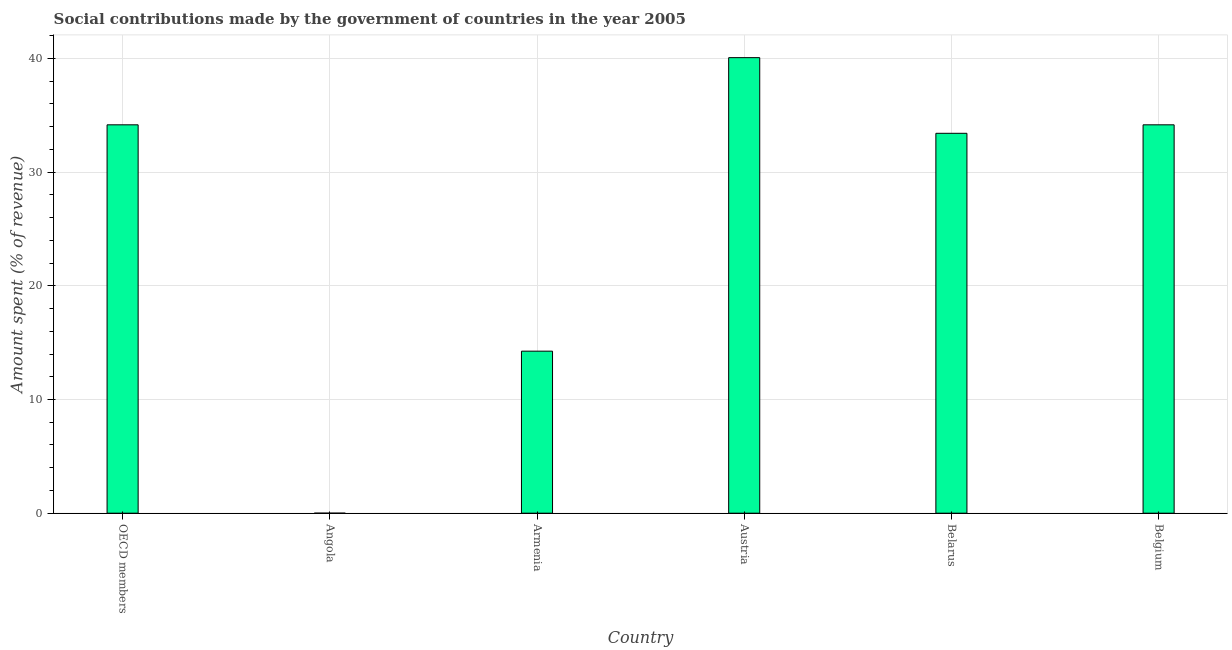Does the graph contain any zero values?
Provide a short and direct response. No. Does the graph contain grids?
Ensure brevity in your answer.  Yes. What is the title of the graph?
Offer a very short reply. Social contributions made by the government of countries in the year 2005. What is the label or title of the Y-axis?
Ensure brevity in your answer.  Amount spent (% of revenue). What is the amount spent in making social contributions in Armenia?
Offer a very short reply. 14.25. Across all countries, what is the maximum amount spent in making social contributions?
Offer a very short reply. 40.08. Across all countries, what is the minimum amount spent in making social contributions?
Make the answer very short. 0. In which country was the amount spent in making social contributions minimum?
Ensure brevity in your answer.  Angola. What is the sum of the amount spent in making social contributions?
Ensure brevity in your answer.  156.09. What is the difference between the amount spent in making social contributions in Angola and OECD members?
Your answer should be compact. -34.16. What is the average amount spent in making social contributions per country?
Give a very brief answer. 26.02. What is the median amount spent in making social contributions?
Give a very brief answer. 33.79. In how many countries, is the amount spent in making social contributions greater than 18 %?
Keep it short and to the point. 4. What is the ratio of the amount spent in making social contributions in Armenia to that in Belgium?
Offer a terse response. 0.42. Is the amount spent in making social contributions in Armenia less than that in Austria?
Ensure brevity in your answer.  Yes. Is the difference between the amount spent in making social contributions in Belarus and Belgium greater than the difference between any two countries?
Ensure brevity in your answer.  No. What is the difference between the highest and the second highest amount spent in making social contributions?
Provide a short and direct response. 5.91. Is the sum of the amount spent in making social contributions in Angola and Belgium greater than the maximum amount spent in making social contributions across all countries?
Make the answer very short. No. What is the difference between the highest and the lowest amount spent in making social contributions?
Keep it short and to the point. 40.07. In how many countries, is the amount spent in making social contributions greater than the average amount spent in making social contributions taken over all countries?
Offer a very short reply. 4. How many bars are there?
Offer a terse response. 6. What is the difference between two consecutive major ticks on the Y-axis?
Ensure brevity in your answer.  10. Are the values on the major ticks of Y-axis written in scientific E-notation?
Your response must be concise. No. What is the Amount spent (% of revenue) in OECD members?
Keep it short and to the point. 34.17. What is the Amount spent (% of revenue) of Angola?
Your answer should be very brief. 0. What is the Amount spent (% of revenue) of Armenia?
Your response must be concise. 14.25. What is the Amount spent (% of revenue) of Austria?
Offer a terse response. 40.08. What is the Amount spent (% of revenue) in Belarus?
Ensure brevity in your answer.  33.42. What is the Amount spent (% of revenue) of Belgium?
Provide a short and direct response. 34.17. What is the difference between the Amount spent (% of revenue) in OECD members and Angola?
Give a very brief answer. 34.16. What is the difference between the Amount spent (% of revenue) in OECD members and Armenia?
Your answer should be very brief. 19.91. What is the difference between the Amount spent (% of revenue) in OECD members and Austria?
Your answer should be very brief. -5.91. What is the difference between the Amount spent (% of revenue) in OECD members and Belarus?
Your answer should be very brief. 0.75. What is the difference between the Amount spent (% of revenue) in OECD members and Belgium?
Keep it short and to the point. 0. What is the difference between the Amount spent (% of revenue) in Angola and Armenia?
Your response must be concise. -14.25. What is the difference between the Amount spent (% of revenue) in Angola and Austria?
Offer a very short reply. -40.07. What is the difference between the Amount spent (% of revenue) in Angola and Belarus?
Make the answer very short. -33.42. What is the difference between the Amount spent (% of revenue) in Angola and Belgium?
Offer a very short reply. -34.16. What is the difference between the Amount spent (% of revenue) in Armenia and Austria?
Make the answer very short. -25.82. What is the difference between the Amount spent (% of revenue) in Armenia and Belarus?
Your answer should be very brief. -19.17. What is the difference between the Amount spent (% of revenue) in Armenia and Belgium?
Offer a very short reply. -19.91. What is the difference between the Amount spent (% of revenue) in Austria and Belarus?
Provide a short and direct response. 6.65. What is the difference between the Amount spent (% of revenue) in Austria and Belgium?
Your response must be concise. 5.91. What is the difference between the Amount spent (% of revenue) in Belarus and Belgium?
Offer a terse response. -0.75. What is the ratio of the Amount spent (% of revenue) in OECD members to that in Angola?
Your response must be concise. 1.10e+04. What is the ratio of the Amount spent (% of revenue) in OECD members to that in Armenia?
Provide a short and direct response. 2.4. What is the ratio of the Amount spent (% of revenue) in OECD members to that in Austria?
Your answer should be compact. 0.85. What is the ratio of the Amount spent (% of revenue) in OECD members to that in Belarus?
Keep it short and to the point. 1.02. What is the ratio of the Amount spent (% of revenue) in OECD members to that in Belgium?
Ensure brevity in your answer.  1. What is the ratio of the Amount spent (% of revenue) in Angola to that in Armenia?
Provide a short and direct response. 0. What is the ratio of the Amount spent (% of revenue) in Angola to that in Austria?
Provide a succinct answer. 0. What is the ratio of the Amount spent (% of revenue) in Angola to that in Belarus?
Give a very brief answer. 0. What is the ratio of the Amount spent (% of revenue) in Angola to that in Belgium?
Provide a short and direct response. 0. What is the ratio of the Amount spent (% of revenue) in Armenia to that in Austria?
Give a very brief answer. 0.36. What is the ratio of the Amount spent (% of revenue) in Armenia to that in Belarus?
Provide a short and direct response. 0.43. What is the ratio of the Amount spent (% of revenue) in Armenia to that in Belgium?
Ensure brevity in your answer.  0.42. What is the ratio of the Amount spent (% of revenue) in Austria to that in Belarus?
Offer a terse response. 1.2. What is the ratio of the Amount spent (% of revenue) in Austria to that in Belgium?
Offer a terse response. 1.17. What is the ratio of the Amount spent (% of revenue) in Belarus to that in Belgium?
Provide a short and direct response. 0.98. 